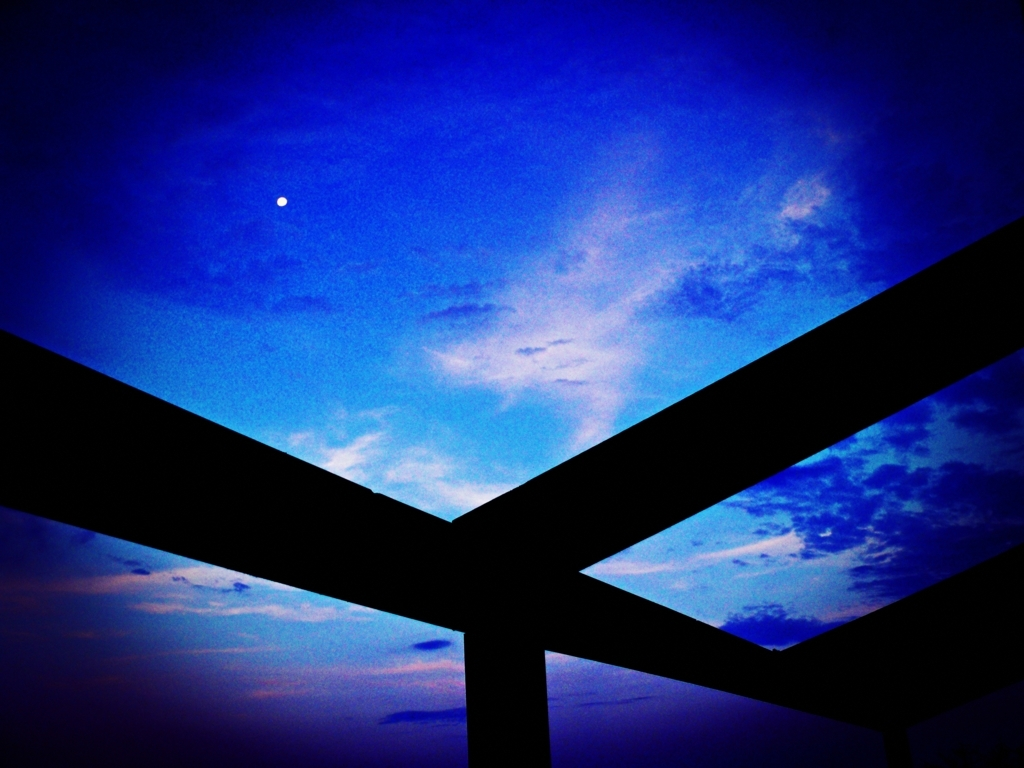If you had to guess, what do you think the foreground silhouettes are a part of? The dark silhouettes in the foreground appear to be structural, possibly part of a man-made construction such as a bridge, a building framework, or an architectural feature. Their strong, clean lines contrast with the soft, organic forms of the clouds, adding an intriguing layer of complexity to the otherwise ethereal scene. 